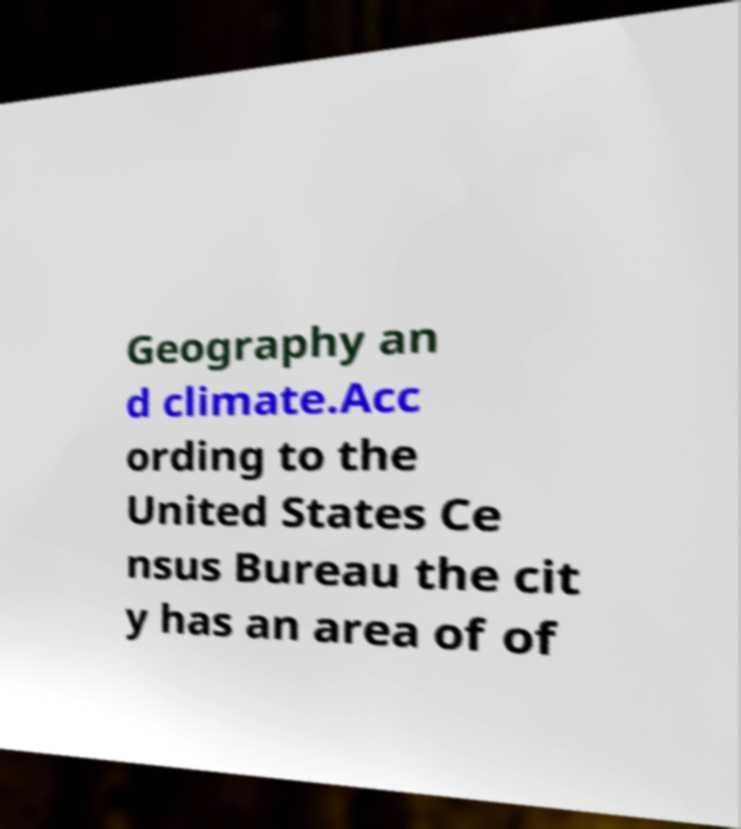Please identify and transcribe the text found in this image. Geography an d climate.Acc ording to the United States Ce nsus Bureau the cit y has an area of of 